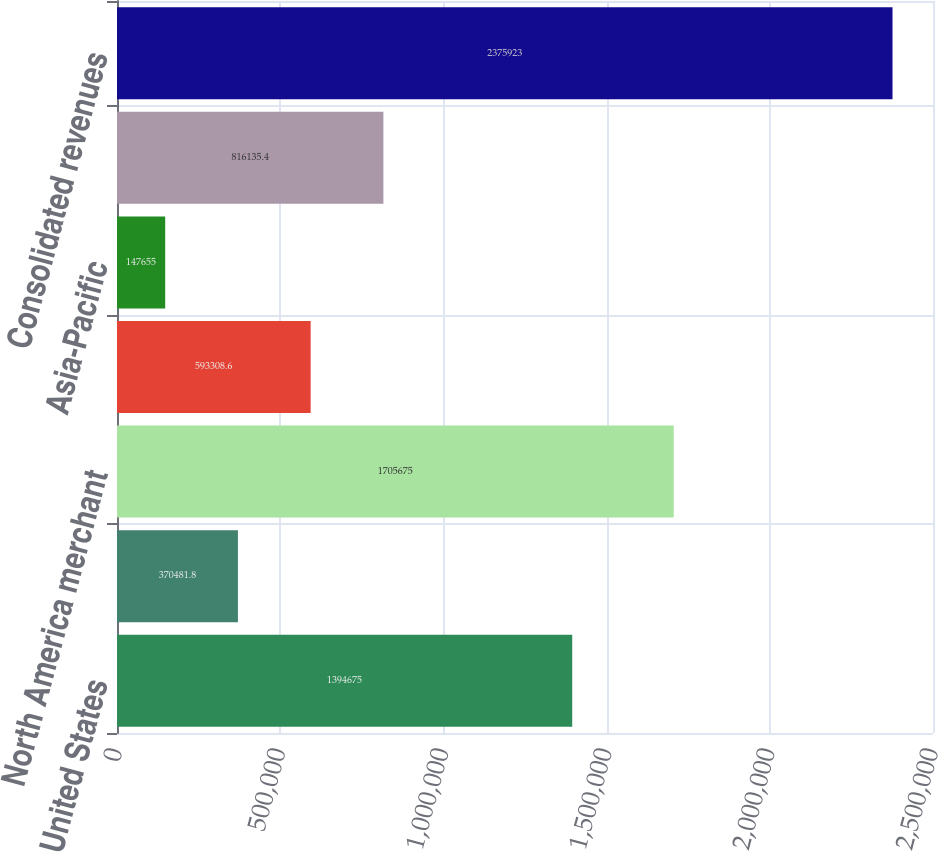Convert chart. <chart><loc_0><loc_0><loc_500><loc_500><bar_chart><fcel>United States<fcel>Canada<fcel>North America merchant<fcel>Europe<fcel>Asia-Pacific<fcel>International merchant<fcel>Consolidated revenues<nl><fcel>1.39468e+06<fcel>370482<fcel>1.70568e+06<fcel>593309<fcel>147655<fcel>816135<fcel>2.37592e+06<nl></chart> 